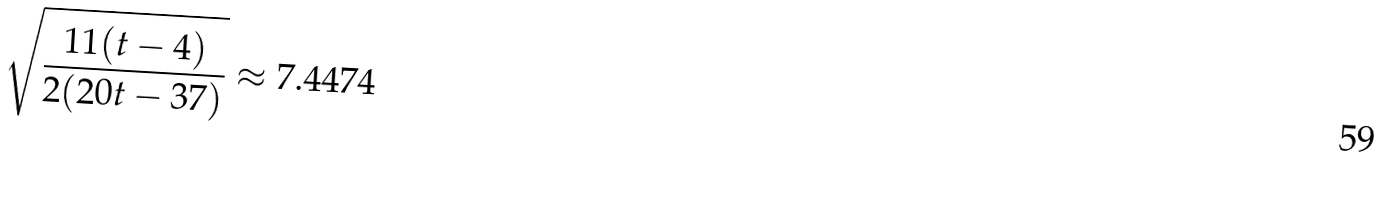<formula> <loc_0><loc_0><loc_500><loc_500>\sqrt { \frac { 1 1 ( t - 4 ) } { 2 ( 2 0 t - 3 7 ) } } \approx 7 . 4 4 7 4</formula> 